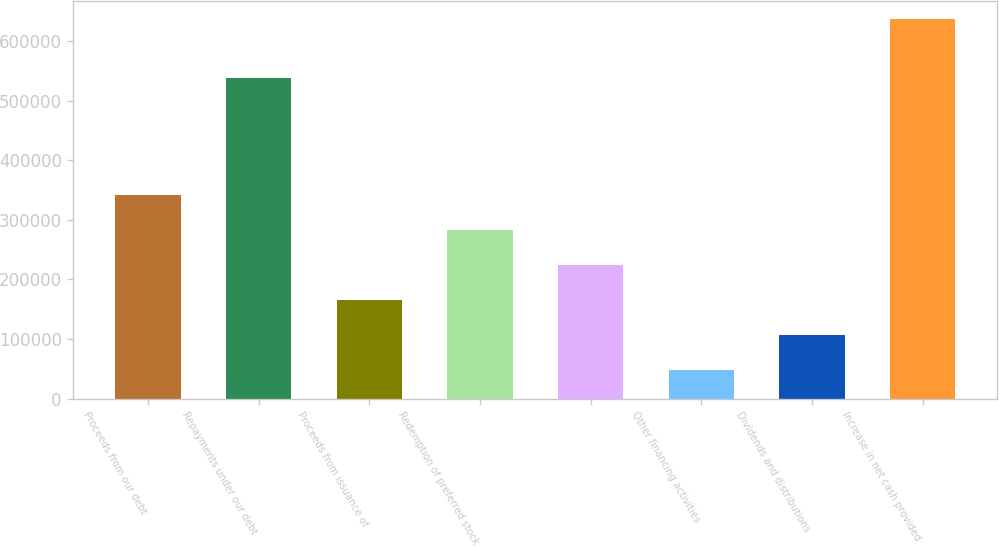Convert chart to OTSL. <chart><loc_0><loc_0><loc_500><loc_500><bar_chart><fcel>Proceeds from our debt<fcel>Repayments under our debt<fcel>Proceeds from issuance of<fcel>Redemption of preferred stock<fcel>Unnamed: 4<fcel>Other financing activities<fcel>Dividends and distributions<fcel>Increase in net cash provided<nl><fcel>342278<fcel>538903<fcel>165839<fcel>283465<fcel>224652<fcel>48213<fcel>107026<fcel>636343<nl></chart> 